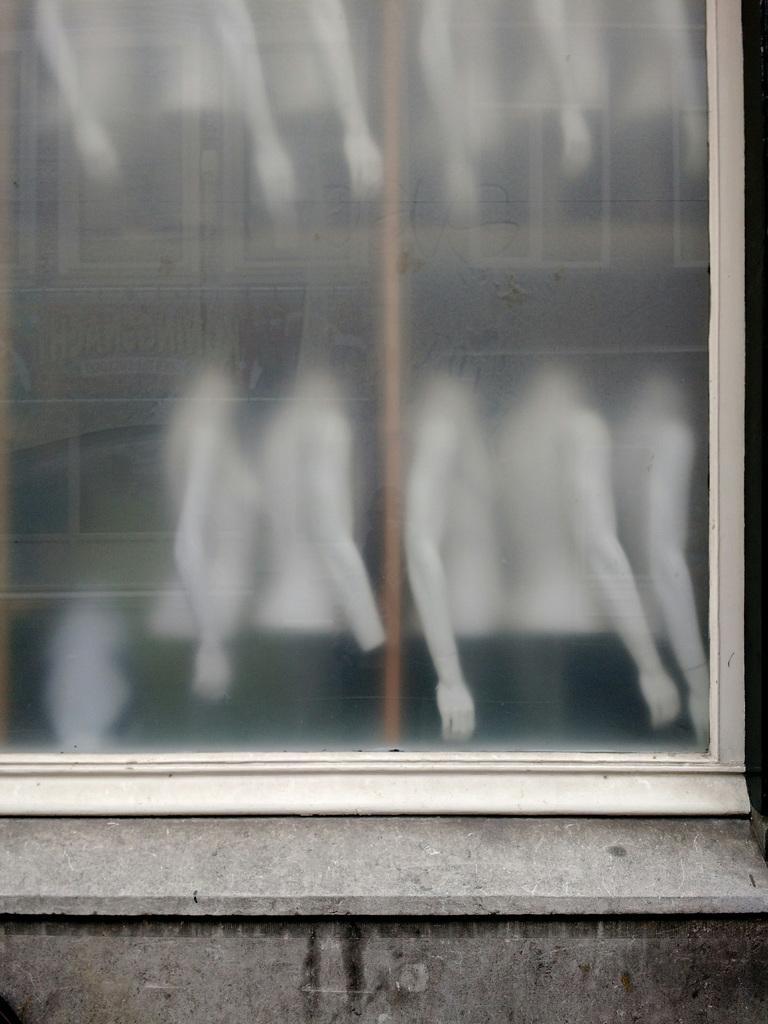Can you describe this image briefly? In this picture we can see a glass and mannequins. 